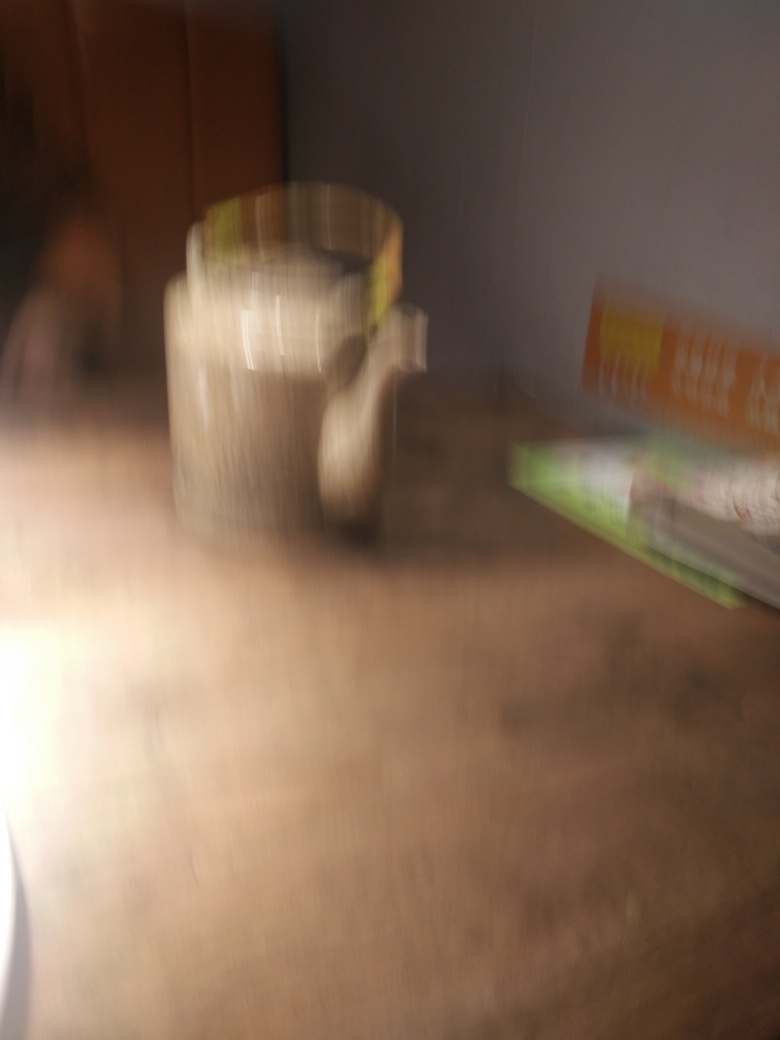What could have caused the blurriness in this image? The blurriness in the image could have been caused by several factors, including movement of the camera or subject during the exposure, incorrect focus settings on the camera, a slow shutter speed not suitable for the lighting conditions, or even an intentional artistic choice by the photographer. 